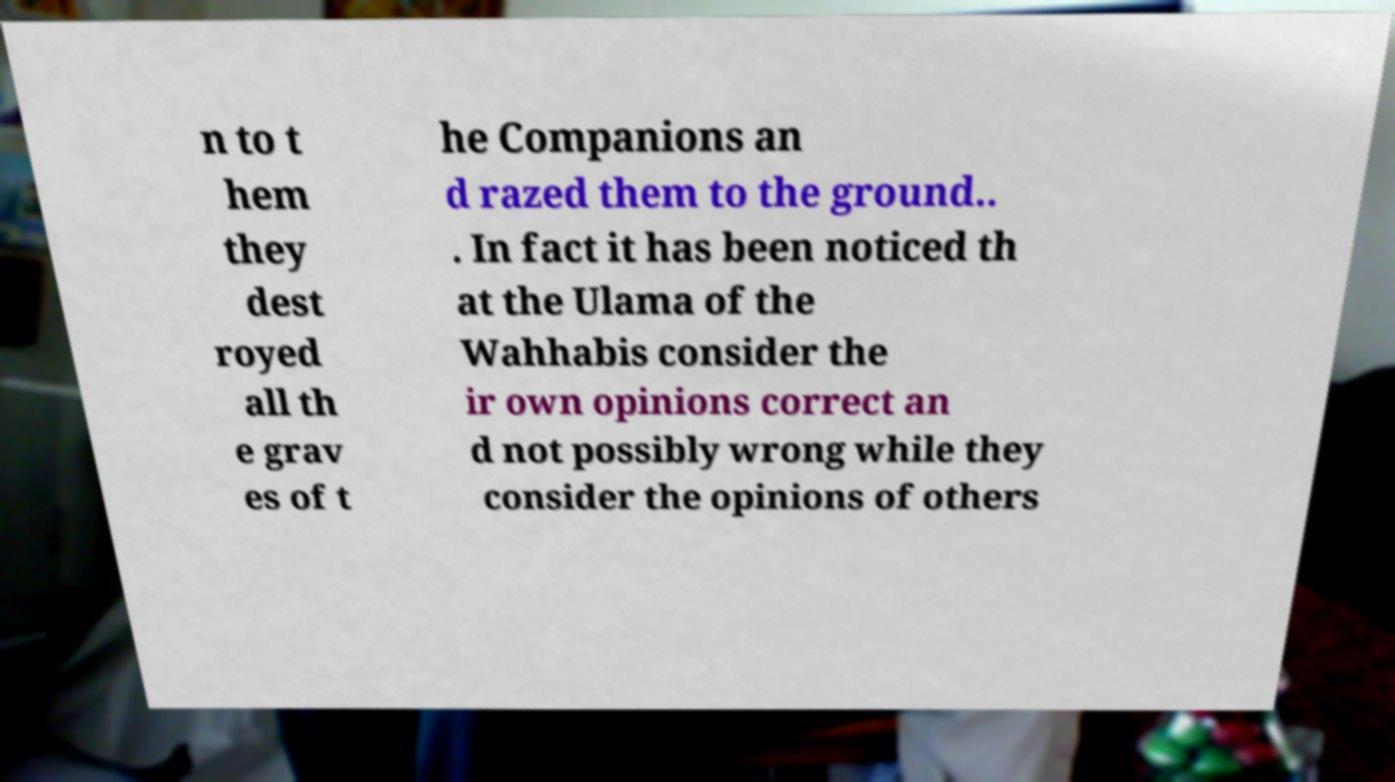For documentation purposes, I need the text within this image transcribed. Could you provide that? n to t hem they dest royed all th e grav es of t he Companions an d razed them to the ground.. . In fact it has been noticed th at the Ulama of the Wahhabis consider the ir own opinions correct an d not possibly wrong while they consider the opinions of others 